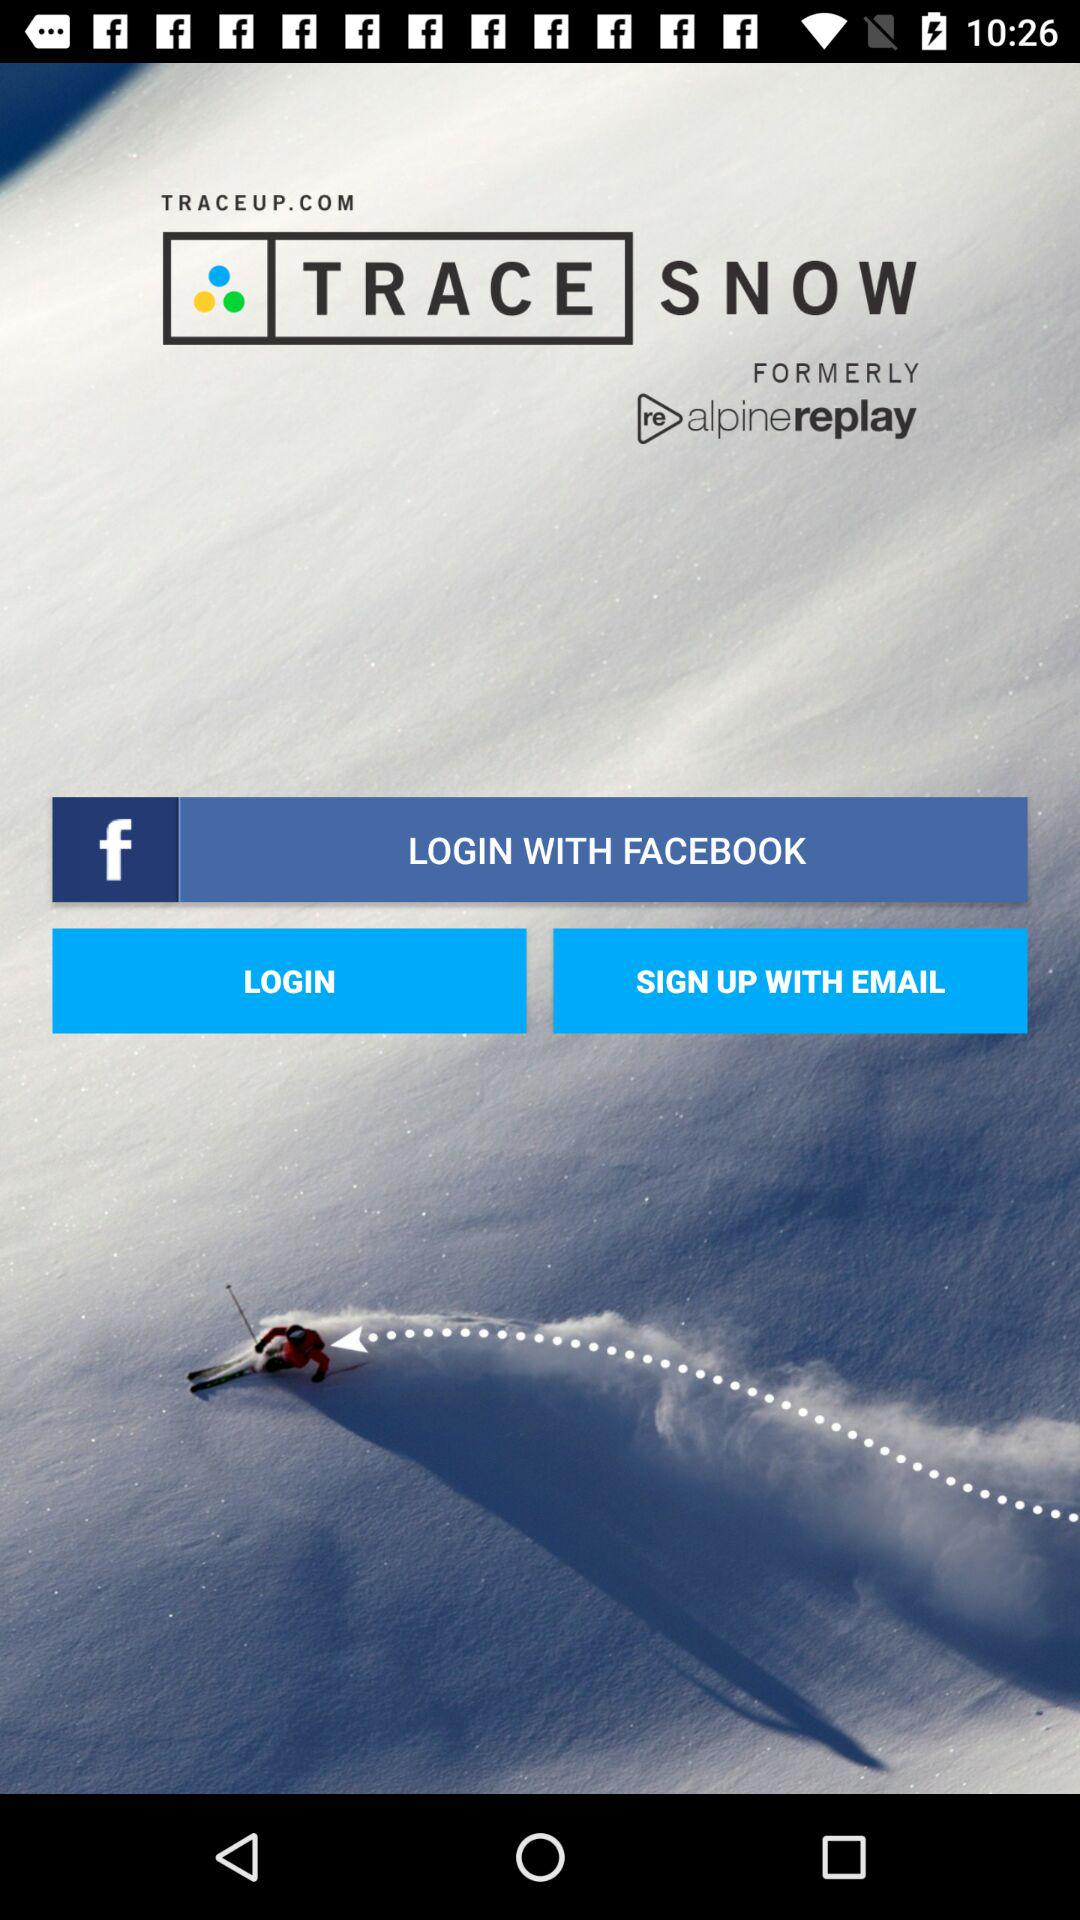What is the application name? The application name is "TRACE SNOW". 